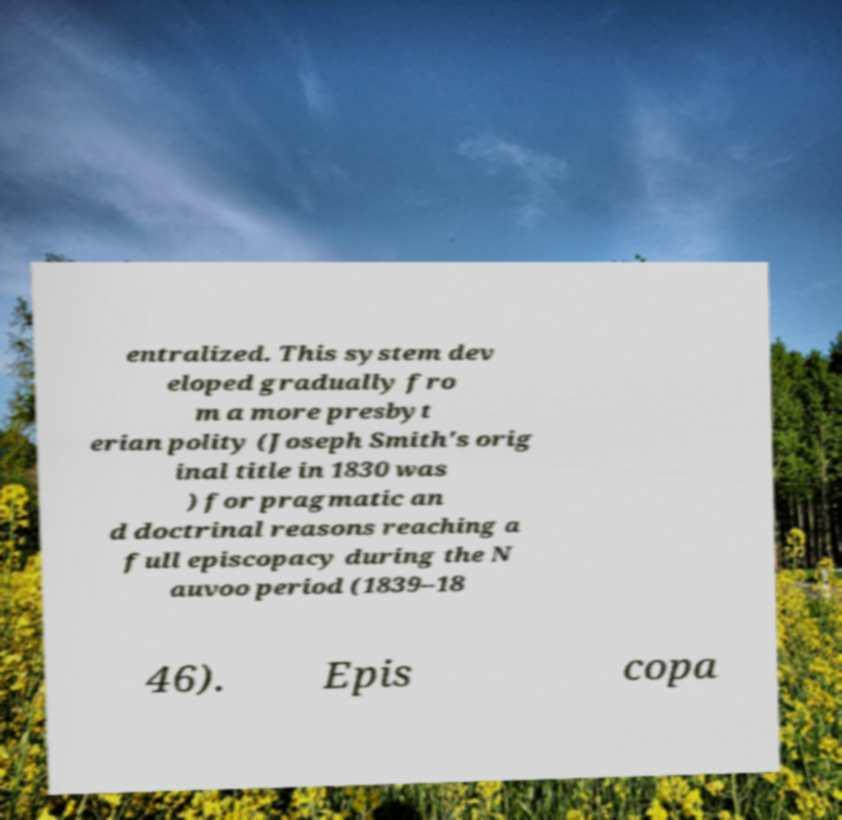What messages or text are displayed in this image? I need them in a readable, typed format. entralized. This system dev eloped gradually fro m a more presbyt erian polity (Joseph Smith's orig inal title in 1830 was ) for pragmatic an d doctrinal reasons reaching a full episcopacy during the N auvoo period (1839–18 46). Epis copa 